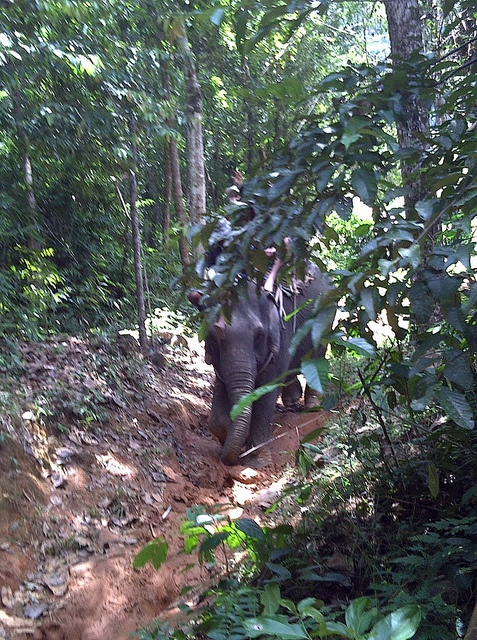Describe the objects in this image and their specific colors. I can see elephant in purple, gray, and black tones, people in purple, black, and gray tones, and people in purple, gray, black, lavender, and darkgray tones in this image. 